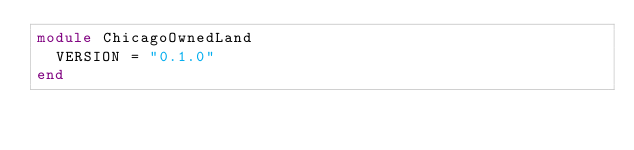<code> <loc_0><loc_0><loc_500><loc_500><_Ruby_>module ChicagoOwnedLand
  VERSION = "0.1.0"
end
</code> 